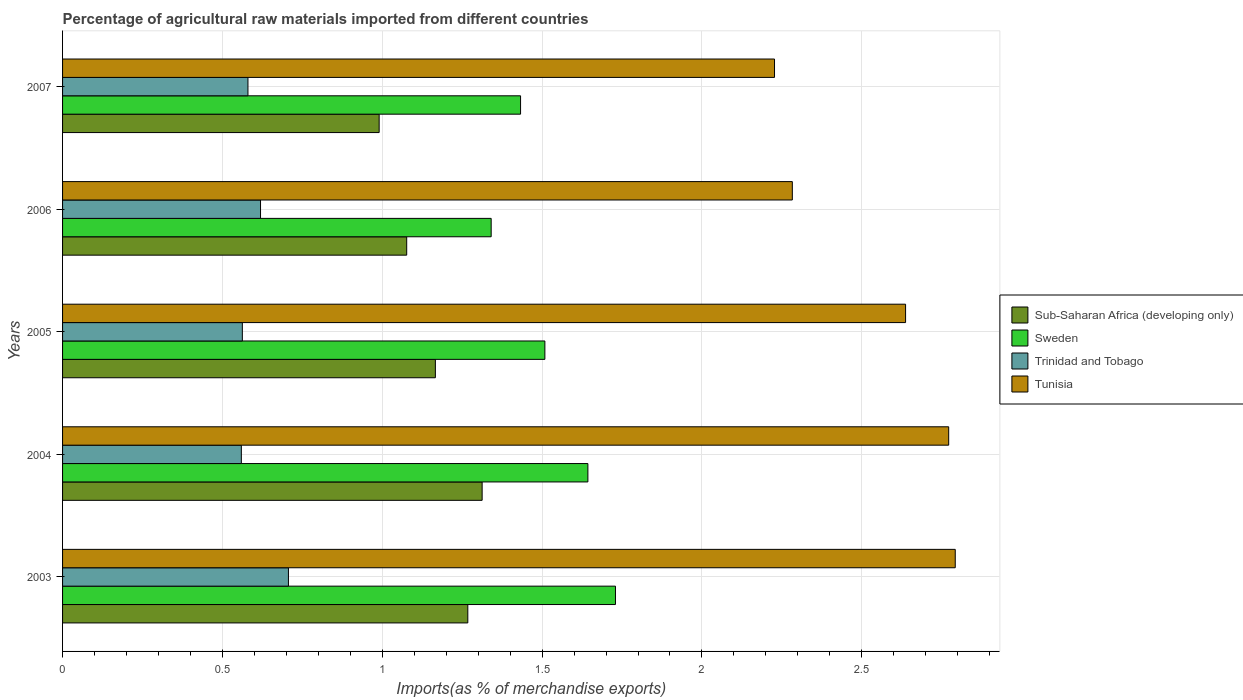How many different coloured bars are there?
Provide a short and direct response. 4. How many groups of bars are there?
Your answer should be compact. 5. How many bars are there on the 3rd tick from the top?
Your answer should be compact. 4. In how many cases, is the number of bars for a given year not equal to the number of legend labels?
Give a very brief answer. 0. What is the percentage of imports to different countries in Sweden in 2005?
Keep it short and to the point. 1.51. Across all years, what is the maximum percentage of imports to different countries in Sweden?
Provide a short and direct response. 1.73. Across all years, what is the minimum percentage of imports to different countries in Trinidad and Tobago?
Offer a very short reply. 0.56. What is the total percentage of imports to different countries in Tunisia in the graph?
Your answer should be compact. 12.71. What is the difference between the percentage of imports to different countries in Sub-Saharan Africa (developing only) in 2004 and that in 2006?
Your response must be concise. 0.24. What is the difference between the percentage of imports to different countries in Sweden in 2006 and the percentage of imports to different countries in Sub-Saharan Africa (developing only) in 2007?
Your answer should be compact. 0.35. What is the average percentage of imports to different countries in Sweden per year?
Ensure brevity in your answer.  1.53. In the year 2006, what is the difference between the percentage of imports to different countries in Sweden and percentage of imports to different countries in Tunisia?
Your response must be concise. -0.94. What is the ratio of the percentage of imports to different countries in Sweden in 2004 to that in 2006?
Provide a succinct answer. 1.23. Is the percentage of imports to different countries in Tunisia in 2005 less than that in 2006?
Make the answer very short. No. What is the difference between the highest and the second highest percentage of imports to different countries in Tunisia?
Your response must be concise. 0.02. What is the difference between the highest and the lowest percentage of imports to different countries in Sweden?
Offer a terse response. 0.39. In how many years, is the percentage of imports to different countries in Sub-Saharan Africa (developing only) greater than the average percentage of imports to different countries in Sub-Saharan Africa (developing only) taken over all years?
Provide a short and direct response. 3. Is the sum of the percentage of imports to different countries in Sweden in 2006 and 2007 greater than the maximum percentage of imports to different countries in Trinidad and Tobago across all years?
Your answer should be compact. Yes. Is it the case that in every year, the sum of the percentage of imports to different countries in Tunisia and percentage of imports to different countries in Sub-Saharan Africa (developing only) is greater than the sum of percentage of imports to different countries in Sweden and percentage of imports to different countries in Trinidad and Tobago?
Your answer should be compact. No. What does the 1st bar from the top in 2004 represents?
Offer a very short reply. Tunisia. What does the 3rd bar from the bottom in 2004 represents?
Ensure brevity in your answer.  Trinidad and Tobago. Is it the case that in every year, the sum of the percentage of imports to different countries in Trinidad and Tobago and percentage of imports to different countries in Sub-Saharan Africa (developing only) is greater than the percentage of imports to different countries in Sweden?
Keep it short and to the point. Yes. How many years are there in the graph?
Provide a succinct answer. 5. Are the values on the major ticks of X-axis written in scientific E-notation?
Make the answer very short. No. Does the graph contain any zero values?
Give a very brief answer. No. Does the graph contain grids?
Ensure brevity in your answer.  Yes. How many legend labels are there?
Keep it short and to the point. 4. What is the title of the graph?
Your answer should be very brief. Percentage of agricultural raw materials imported from different countries. What is the label or title of the X-axis?
Give a very brief answer. Imports(as % of merchandise exports). What is the Imports(as % of merchandise exports) in Sub-Saharan Africa (developing only) in 2003?
Provide a succinct answer. 1.27. What is the Imports(as % of merchandise exports) in Sweden in 2003?
Make the answer very short. 1.73. What is the Imports(as % of merchandise exports) in Trinidad and Tobago in 2003?
Your answer should be very brief. 0.71. What is the Imports(as % of merchandise exports) of Tunisia in 2003?
Make the answer very short. 2.79. What is the Imports(as % of merchandise exports) of Sub-Saharan Africa (developing only) in 2004?
Make the answer very short. 1.31. What is the Imports(as % of merchandise exports) of Sweden in 2004?
Give a very brief answer. 1.64. What is the Imports(as % of merchandise exports) of Trinidad and Tobago in 2004?
Provide a short and direct response. 0.56. What is the Imports(as % of merchandise exports) in Tunisia in 2004?
Offer a very short reply. 2.77. What is the Imports(as % of merchandise exports) of Sub-Saharan Africa (developing only) in 2005?
Provide a succinct answer. 1.17. What is the Imports(as % of merchandise exports) in Sweden in 2005?
Make the answer very short. 1.51. What is the Imports(as % of merchandise exports) of Trinidad and Tobago in 2005?
Your answer should be very brief. 0.56. What is the Imports(as % of merchandise exports) in Tunisia in 2005?
Offer a very short reply. 2.64. What is the Imports(as % of merchandise exports) in Sub-Saharan Africa (developing only) in 2006?
Keep it short and to the point. 1.08. What is the Imports(as % of merchandise exports) in Sweden in 2006?
Give a very brief answer. 1.34. What is the Imports(as % of merchandise exports) of Trinidad and Tobago in 2006?
Offer a terse response. 0.62. What is the Imports(as % of merchandise exports) in Tunisia in 2006?
Keep it short and to the point. 2.28. What is the Imports(as % of merchandise exports) in Sub-Saharan Africa (developing only) in 2007?
Make the answer very short. 0.99. What is the Imports(as % of merchandise exports) in Sweden in 2007?
Your answer should be compact. 1.43. What is the Imports(as % of merchandise exports) in Trinidad and Tobago in 2007?
Your answer should be very brief. 0.58. What is the Imports(as % of merchandise exports) of Tunisia in 2007?
Give a very brief answer. 2.23. Across all years, what is the maximum Imports(as % of merchandise exports) of Sub-Saharan Africa (developing only)?
Your answer should be very brief. 1.31. Across all years, what is the maximum Imports(as % of merchandise exports) in Sweden?
Provide a succinct answer. 1.73. Across all years, what is the maximum Imports(as % of merchandise exports) of Trinidad and Tobago?
Offer a terse response. 0.71. Across all years, what is the maximum Imports(as % of merchandise exports) in Tunisia?
Your answer should be very brief. 2.79. Across all years, what is the minimum Imports(as % of merchandise exports) of Sub-Saharan Africa (developing only)?
Offer a terse response. 0.99. Across all years, what is the minimum Imports(as % of merchandise exports) of Sweden?
Provide a short and direct response. 1.34. Across all years, what is the minimum Imports(as % of merchandise exports) in Trinidad and Tobago?
Provide a short and direct response. 0.56. Across all years, what is the minimum Imports(as % of merchandise exports) of Tunisia?
Keep it short and to the point. 2.23. What is the total Imports(as % of merchandise exports) in Sub-Saharan Africa (developing only) in the graph?
Keep it short and to the point. 5.81. What is the total Imports(as % of merchandise exports) in Sweden in the graph?
Offer a terse response. 7.65. What is the total Imports(as % of merchandise exports) in Trinidad and Tobago in the graph?
Give a very brief answer. 3.03. What is the total Imports(as % of merchandise exports) in Tunisia in the graph?
Your response must be concise. 12.71. What is the difference between the Imports(as % of merchandise exports) in Sub-Saharan Africa (developing only) in 2003 and that in 2004?
Give a very brief answer. -0.04. What is the difference between the Imports(as % of merchandise exports) of Sweden in 2003 and that in 2004?
Provide a succinct answer. 0.09. What is the difference between the Imports(as % of merchandise exports) of Trinidad and Tobago in 2003 and that in 2004?
Make the answer very short. 0.15. What is the difference between the Imports(as % of merchandise exports) of Tunisia in 2003 and that in 2004?
Make the answer very short. 0.02. What is the difference between the Imports(as % of merchandise exports) of Sub-Saharan Africa (developing only) in 2003 and that in 2005?
Keep it short and to the point. 0.1. What is the difference between the Imports(as % of merchandise exports) of Sweden in 2003 and that in 2005?
Provide a succinct answer. 0.22. What is the difference between the Imports(as % of merchandise exports) of Trinidad and Tobago in 2003 and that in 2005?
Keep it short and to the point. 0.14. What is the difference between the Imports(as % of merchandise exports) in Tunisia in 2003 and that in 2005?
Make the answer very short. 0.16. What is the difference between the Imports(as % of merchandise exports) in Sub-Saharan Africa (developing only) in 2003 and that in 2006?
Ensure brevity in your answer.  0.19. What is the difference between the Imports(as % of merchandise exports) in Sweden in 2003 and that in 2006?
Ensure brevity in your answer.  0.39. What is the difference between the Imports(as % of merchandise exports) of Trinidad and Tobago in 2003 and that in 2006?
Provide a short and direct response. 0.09. What is the difference between the Imports(as % of merchandise exports) in Tunisia in 2003 and that in 2006?
Ensure brevity in your answer.  0.51. What is the difference between the Imports(as % of merchandise exports) of Sub-Saharan Africa (developing only) in 2003 and that in 2007?
Ensure brevity in your answer.  0.28. What is the difference between the Imports(as % of merchandise exports) of Sweden in 2003 and that in 2007?
Offer a terse response. 0.3. What is the difference between the Imports(as % of merchandise exports) in Trinidad and Tobago in 2003 and that in 2007?
Make the answer very short. 0.13. What is the difference between the Imports(as % of merchandise exports) of Tunisia in 2003 and that in 2007?
Provide a short and direct response. 0.57. What is the difference between the Imports(as % of merchandise exports) in Sub-Saharan Africa (developing only) in 2004 and that in 2005?
Keep it short and to the point. 0.15. What is the difference between the Imports(as % of merchandise exports) in Sweden in 2004 and that in 2005?
Provide a succinct answer. 0.13. What is the difference between the Imports(as % of merchandise exports) of Trinidad and Tobago in 2004 and that in 2005?
Give a very brief answer. -0. What is the difference between the Imports(as % of merchandise exports) in Tunisia in 2004 and that in 2005?
Give a very brief answer. 0.13. What is the difference between the Imports(as % of merchandise exports) in Sub-Saharan Africa (developing only) in 2004 and that in 2006?
Make the answer very short. 0.24. What is the difference between the Imports(as % of merchandise exports) in Sweden in 2004 and that in 2006?
Provide a short and direct response. 0.3. What is the difference between the Imports(as % of merchandise exports) of Trinidad and Tobago in 2004 and that in 2006?
Your response must be concise. -0.06. What is the difference between the Imports(as % of merchandise exports) in Tunisia in 2004 and that in 2006?
Your answer should be compact. 0.49. What is the difference between the Imports(as % of merchandise exports) in Sub-Saharan Africa (developing only) in 2004 and that in 2007?
Provide a succinct answer. 0.32. What is the difference between the Imports(as % of merchandise exports) of Sweden in 2004 and that in 2007?
Your answer should be compact. 0.21. What is the difference between the Imports(as % of merchandise exports) of Trinidad and Tobago in 2004 and that in 2007?
Give a very brief answer. -0.02. What is the difference between the Imports(as % of merchandise exports) of Tunisia in 2004 and that in 2007?
Your answer should be compact. 0.54. What is the difference between the Imports(as % of merchandise exports) in Sub-Saharan Africa (developing only) in 2005 and that in 2006?
Your answer should be compact. 0.09. What is the difference between the Imports(as % of merchandise exports) in Sweden in 2005 and that in 2006?
Make the answer very short. 0.17. What is the difference between the Imports(as % of merchandise exports) in Trinidad and Tobago in 2005 and that in 2006?
Provide a succinct answer. -0.06. What is the difference between the Imports(as % of merchandise exports) in Tunisia in 2005 and that in 2006?
Your response must be concise. 0.35. What is the difference between the Imports(as % of merchandise exports) in Sub-Saharan Africa (developing only) in 2005 and that in 2007?
Keep it short and to the point. 0.18. What is the difference between the Imports(as % of merchandise exports) in Sweden in 2005 and that in 2007?
Keep it short and to the point. 0.08. What is the difference between the Imports(as % of merchandise exports) of Trinidad and Tobago in 2005 and that in 2007?
Ensure brevity in your answer.  -0.02. What is the difference between the Imports(as % of merchandise exports) in Tunisia in 2005 and that in 2007?
Give a very brief answer. 0.41. What is the difference between the Imports(as % of merchandise exports) in Sub-Saharan Africa (developing only) in 2006 and that in 2007?
Offer a terse response. 0.09. What is the difference between the Imports(as % of merchandise exports) of Sweden in 2006 and that in 2007?
Offer a very short reply. -0.09. What is the difference between the Imports(as % of merchandise exports) in Trinidad and Tobago in 2006 and that in 2007?
Your answer should be compact. 0.04. What is the difference between the Imports(as % of merchandise exports) in Tunisia in 2006 and that in 2007?
Your answer should be compact. 0.06. What is the difference between the Imports(as % of merchandise exports) in Sub-Saharan Africa (developing only) in 2003 and the Imports(as % of merchandise exports) in Sweden in 2004?
Provide a succinct answer. -0.38. What is the difference between the Imports(as % of merchandise exports) of Sub-Saharan Africa (developing only) in 2003 and the Imports(as % of merchandise exports) of Trinidad and Tobago in 2004?
Your answer should be very brief. 0.71. What is the difference between the Imports(as % of merchandise exports) in Sub-Saharan Africa (developing only) in 2003 and the Imports(as % of merchandise exports) in Tunisia in 2004?
Your answer should be very brief. -1.5. What is the difference between the Imports(as % of merchandise exports) of Sweden in 2003 and the Imports(as % of merchandise exports) of Trinidad and Tobago in 2004?
Your answer should be very brief. 1.17. What is the difference between the Imports(as % of merchandise exports) of Sweden in 2003 and the Imports(as % of merchandise exports) of Tunisia in 2004?
Offer a terse response. -1.04. What is the difference between the Imports(as % of merchandise exports) of Trinidad and Tobago in 2003 and the Imports(as % of merchandise exports) of Tunisia in 2004?
Ensure brevity in your answer.  -2.07. What is the difference between the Imports(as % of merchandise exports) in Sub-Saharan Africa (developing only) in 2003 and the Imports(as % of merchandise exports) in Sweden in 2005?
Make the answer very short. -0.24. What is the difference between the Imports(as % of merchandise exports) in Sub-Saharan Africa (developing only) in 2003 and the Imports(as % of merchandise exports) in Trinidad and Tobago in 2005?
Your response must be concise. 0.71. What is the difference between the Imports(as % of merchandise exports) in Sub-Saharan Africa (developing only) in 2003 and the Imports(as % of merchandise exports) in Tunisia in 2005?
Offer a terse response. -1.37. What is the difference between the Imports(as % of merchandise exports) of Sweden in 2003 and the Imports(as % of merchandise exports) of Trinidad and Tobago in 2005?
Keep it short and to the point. 1.17. What is the difference between the Imports(as % of merchandise exports) of Sweden in 2003 and the Imports(as % of merchandise exports) of Tunisia in 2005?
Provide a succinct answer. -0.91. What is the difference between the Imports(as % of merchandise exports) in Trinidad and Tobago in 2003 and the Imports(as % of merchandise exports) in Tunisia in 2005?
Your answer should be compact. -1.93. What is the difference between the Imports(as % of merchandise exports) in Sub-Saharan Africa (developing only) in 2003 and the Imports(as % of merchandise exports) in Sweden in 2006?
Your answer should be very brief. -0.07. What is the difference between the Imports(as % of merchandise exports) in Sub-Saharan Africa (developing only) in 2003 and the Imports(as % of merchandise exports) in Trinidad and Tobago in 2006?
Offer a very short reply. 0.65. What is the difference between the Imports(as % of merchandise exports) of Sub-Saharan Africa (developing only) in 2003 and the Imports(as % of merchandise exports) of Tunisia in 2006?
Provide a short and direct response. -1.02. What is the difference between the Imports(as % of merchandise exports) of Sweden in 2003 and the Imports(as % of merchandise exports) of Trinidad and Tobago in 2006?
Your answer should be very brief. 1.11. What is the difference between the Imports(as % of merchandise exports) in Sweden in 2003 and the Imports(as % of merchandise exports) in Tunisia in 2006?
Offer a terse response. -0.55. What is the difference between the Imports(as % of merchandise exports) in Trinidad and Tobago in 2003 and the Imports(as % of merchandise exports) in Tunisia in 2006?
Ensure brevity in your answer.  -1.58. What is the difference between the Imports(as % of merchandise exports) of Sub-Saharan Africa (developing only) in 2003 and the Imports(as % of merchandise exports) of Sweden in 2007?
Provide a short and direct response. -0.17. What is the difference between the Imports(as % of merchandise exports) in Sub-Saharan Africa (developing only) in 2003 and the Imports(as % of merchandise exports) in Trinidad and Tobago in 2007?
Ensure brevity in your answer.  0.69. What is the difference between the Imports(as % of merchandise exports) in Sub-Saharan Africa (developing only) in 2003 and the Imports(as % of merchandise exports) in Tunisia in 2007?
Your response must be concise. -0.96. What is the difference between the Imports(as % of merchandise exports) in Sweden in 2003 and the Imports(as % of merchandise exports) in Trinidad and Tobago in 2007?
Keep it short and to the point. 1.15. What is the difference between the Imports(as % of merchandise exports) in Sweden in 2003 and the Imports(as % of merchandise exports) in Tunisia in 2007?
Provide a short and direct response. -0.5. What is the difference between the Imports(as % of merchandise exports) of Trinidad and Tobago in 2003 and the Imports(as % of merchandise exports) of Tunisia in 2007?
Your response must be concise. -1.52. What is the difference between the Imports(as % of merchandise exports) of Sub-Saharan Africa (developing only) in 2004 and the Imports(as % of merchandise exports) of Sweden in 2005?
Give a very brief answer. -0.2. What is the difference between the Imports(as % of merchandise exports) in Sub-Saharan Africa (developing only) in 2004 and the Imports(as % of merchandise exports) in Trinidad and Tobago in 2005?
Ensure brevity in your answer.  0.75. What is the difference between the Imports(as % of merchandise exports) of Sub-Saharan Africa (developing only) in 2004 and the Imports(as % of merchandise exports) of Tunisia in 2005?
Your response must be concise. -1.32. What is the difference between the Imports(as % of merchandise exports) in Sweden in 2004 and the Imports(as % of merchandise exports) in Trinidad and Tobago in 2005?
Provide a short and direct response. 1.08. What is the difference between the Imports(as % of merchandise exports) of Sweden in 2004 and the Imports(as % of merchandise exports) of Tunisia in 2005?
Offer a terse response. -0.99. What is the difference between the Imports(as % of merchandise exports) in Trinidad and Tobago in 2004 and the Imports(as % of merchandise exports) in Tunisia in 2005?
Ensure brevity in your answer.  -2.08. What is the difference between the Imports(as % of merchandise exports) of Sub-Saharan Africa (developing only) in 2004 and the Imports(as % of merchandise exports) of Sweden in 2006?
Your response must be concise. -0.03. What is the difference between the Imports(as % of merchandise exports) of Sub-Saharan Africa (developing only) in 2004 and the Imports(as % of merchandise exports) of Trinidad and Tobago in 2006?
Keep it short and to the point. 0.69. What is the difference between the Imports(as % of merchandise exports) in Sub-Saharan Africa (developing only) in 2004 and the Imports(as % of merchandise exports) in Tunisia in 2006?
Provide a short and direct response. -0.97. What is the difference between the Imports(as % of merchandise exports) in Sweden in 2004 and the Imports(as % of merchandise exports) in Trinidad and Tobago in 2006?
Ensure brevity in your answer.  1.02. What is the difference between the Imports(as % of merchandise exports) in Sweden in 2004 and the Imports(as % of merchandise exports) in Tunisia in 2006?
Offer a very short reply. -0.64. What is the difference between the Imports(as % of merchandise exports) of Trinidad and Tobago in 2004 and the Imports(as % of merchandise exports) of Tunisia in 2006?
Your response must be concise. -1.72. What is the difference between the Imports(as % of merchandise exports) in Sub-Saharan Africa (developing only) in 2004 and the Imports(as % of merchandise exports) in Sweden in 2007?
Provide a succinct answer. -0.12. What is the difference between the Imports(as % of merchandise exports) of Sub-Saharan Africa (developing only) in 2004 and the Imports(as % of merchandise exports) of Trinidad and Tobago in 2007?
Keep it short and to the point. 0.73. What is the difference between the Imports(as % of merchandise exports) of Sub-Saharan Africa (developing only) in 2004 and the Imports(as % of merchandise exports) of Tunisia in 2007?
Ensure brevity in your answer.  -0.91. What is the difference between the Imports(as % of merchandise exports) of Sweden in 2004 and the Imports(as % of merchandise exports) of Trinidad and Tobago in 2007?
Provide a succinct answer. 1.06. What is the difference between the Imports(as % of merchandise exports) in Sweden in 2004 and the Imports(as % of merchandise exports) in Tunisia in 2007?
Give a very brief answer. -0.58. What is the difference between the Imports(as % of merchandise exports) of Trinidad and Tobago in 2004 and the Imports(as % of merchandise exports) of Tunisia in 2007?
Your response must be concise. -1.67. What is the difference between the Imports(as % of merchandise exports) of Sub-Saharan Africa (developing only) in 2005 and the Imports(as % of merchandise exports) of Sweden in 2006?
Offer a terse response. -0.17. What is the difference between the Imports(as % of merchandise exports) in Sub-Saharan Africa (developing only) in 2005 and the Imports(as % of merchandise exports) in Trinidad and Tobago in 2006?
Provide a succinct answer. 0.55. What is the difference between the Imports(as % of merchandise exports) in Sub-Saharan Africa (developing only) in 2005 and the Imports(as % of merchandise exports) in Tunisia in 2006?
Provide a short and direct response. -1.12. What is the difference between the Imports(as % of merchandise exports) in Sweden in 2005 and the Imports(as % of merchandise exports) in Trinidad and Tobago in 2006?
Make the answer very short. 0.89. What is the difference between the Imports(as % of merchandise exports) of Sweden in 2005 and the Imports(as % of merchandise exports) of Tunisia in 2006?
Your response must be concise. -0.77. What is the difference between the Imports(as % of merchandise exports) in Trinidad and Tobago in 2005 and the Imports(as % of merchandise exports) in Tunisia in 2006?
Your answer should be compact. -1.72. What is the difference between the Imports(as % of merchandise exports) of Sub-Saharan Africa (developing only) in 2005 and the Imports(as % of merchandise exports) of Sweden in 2007?
Your answer should be very brief. -0.27. What is the difference between the Imports(as % of merchandise exports) in Sub-Saharan Africa (developing only) in 2005 and the Imports(as % of merchandise exports) in Trinidad and Tobago in 2007?
Keep it short and to the point. 0.59. What is the difference between the Imports(as % of merchandise exports) of Sub-Saharan Africa (developing only) in 2005 and the Imports(as % of merchandise exports) of Tunisia in 2007?
Ensure brevity in your answer.  -1.06. What is the difference between the Imports(as % of merchandise exports) in Sweden in 2005 and the Imports(as % of merchandise exports) in Trinidad and Tobago in 2007?
Offer a very short reply. 0.93. What is the difference between the Imports(as % of merchandise exports) of Sweden in 2005 and the Imports(as % of merchandise exports) of Tunisia in 2007?
Ensure brevity in your answer.  -0.72. What is the difference between the Imports(as % of merchandise exports) in Trinidad and Tobago in 2005 and the Imports(as % of merchandise exports) in Tunisia in 2007?
Provide a short and direct response. -1.66. What is the difference between the Imports(as % of merchandise exports) of Sub-Saharan Africa (developing only) in 2006 and the Imports(as % of merchandise exports) of Sweden in 2007?
Make the answer very short. -0.36. What is the difference between the Imports(as % of merchandise exports) of Sub-Saharan Africa (developing only) in 2006 and the Imports(as % of merchandise exports) of Trinidad and Tobago in 2007?
Offer a terse response. 0.5. What is the difference between the Imports(as % of merchandise exports) in Sub-Saharan Africa (developing only) in 2006 and the Imports(as % of merchandise exports) in Tunisia in 2007?
Ensure brevity in your answer.  -1.15. What is the difference between the Imports(as % of merchandise exports) in Sweden in 2006 and the Imports(as % of merchandise exports) in Trinidad and Tobago in 2007?
Ensure brevity in your answer.  0.76. What is the difference between the Imports(as % of merchandise exports) of Sweden in 2006 and the Imports(as % of merchandise exports) of Tunisia in 2007?
Ensure brevity in your answer.  -0.89. What is the difference between the Imports(as % of merchandise exports) of Trinidad and Tobago in 2006 and the Imports(as % of merchandise exports) of Tunisia in 2007?
Offer a very short reply. -1.61. What is the average Imports(as % of merchandise exports) in Sub-Saharan Africa (developing only) per year?
Provide a succinct answer. 1.16. What is the average Imports(as % of merchandise exports) in Sweden per year?
Make the answer very short. 1.53. What is the average Imports(as % of merchandise exports) in Trinidad and Tobago per year?
Provide a short and direct response. 0.61. What is the average Imports(as % of merchandise exports) in Tunisia per year?
Keep it short and to the point. 2.54. In the year 2003, what is the difference between the Imports(as % of merchandise exports) of Sub-Saharan Africa (developing only) and Imports(as % of merchandise exports) of Sweden?
Offer a very short reply. -0.46. In the year 2003, what is the difference between the Imports(as % of merchandise exports) of Sub-Saharan Africa (developing only) and Imports(as % of merchandise exports) of Trinidad and Tobago?
Provide a succinct answer. 0.56. In the year 2003, what is the difference between the Imports(as % of merchandise exports) in Sub-Saharan Africa (developing only) and Imports(as % of merchandise exports) in Tunisia?
Keep it short and to the point. -1.52. In the year 2003, what is the difference between the Imports(as % of merchandise exports) in Sweden and Imports(as % of merchandise exports) in Trinidad and Tobago?
Your response must be concise. 1.02. In the year 2003, what is the difference between the Imports(as % of merchandise exports) of Sweden and Imports(as % of merchandise exports) of Tunisia?
Provide a short and direct response. -1.06. In the year 2003, what is the difference between the Imports(as % of merchandise exports) in Trinidad and Tobago and Imports(as % of merchandise exports) in Tunisia?
Provide a succinct answer. -2.09. In the year 2004, what is the difference between the Imports(as % of merchandise exports) in Sub-Saharan Africa (developing only) and Imports(as % of merchandise exports) in Sweden?
Offer a terse response. -0.33. In the year 2004, what is the difference between the Imports(as % of merchandise exports) of Sub-Saharan Africa (developing only) and Imports(as % of merchandise exports) of Trinidad and Tobago?
Your response must be concise. 0.75. In the year 2004, what is the difference between the Imports(as % of merchandise exports) in Sub-Saharan Africa (developing only) and Imports(as % of merchandise exports) in Tunisia?
Keep it short and to the point. -1.46. In the year 2004, what is the difference between the Imports(as % of merchandise exports) of Sweden and Imports(as % of merchandise exports) of Trinidad and Tobago?
Offer a very short reply. 1.08. In the year 2004, what is the difference between the Imports(as % of merchandise exports) of Sweden and Imports(as % of merchandise exports) of Tunisia?
Provide a succinct answer. -1.13. In the year 2004, what is the difference between the Imports(as % of merchandise exports) in Trinidad and Tobago and Imports(as % of merchandise exports) in Tunisia?
Give a very brief answer. -2.21. In the year 2005, what is the difference between the Imports(as % of merchandise exports) of Sub-Saharan Africa (developing only) and Imports(as % of merchandise exports) of Sweden?
Give a very brief answer. -0.34. In the year 2005, what is the difference between the Imports(as % of merchandise exports) of Sub-Saharan Africa (developing only) and Imports(as % of merchandise exports) of Trinidad and Tobago?
Your answer should be compact. 0.6. In the year 2005, what is the difference between the Imports(as % of merchandise exports) of Sub-Saharan Africa (developing only) and Imports(as % of merchandise exports) of Tunisia?
Give a very brief answer. -1.47. In the year 2005, what is the difference between the Imports(as % of merchandise exports) in Sweden and Imports(as % of merchandise exports) in Trinidad and Tobago?
Your answer should be very brief. 0.95. In the year 2005, what is the difference between the Imports(as % of merchandise exports) of Sweden and Imports(as % of merchandise exports) of Tunisia?
Provide a succinct answer. -1.13. In the year 2005, what is the difference between the Imports(as % of merchandise exports) in Trinidad and Tobago and Imports(as % of merchandise exports) in Tunisia?
Ensure brevity in your answer.  -2.07. In the year 2006, what is the difference between the Imports(as % of merchandise exports) of Sub-Saharan Africa (developing only) and Imports(as % of merchandise exports) of Sweden?
Your answer should be compact. -0.26. In the year 2006, what is the difference between the Imports(as % of merchandise exports) of Sub-Saharan Africa (developing only) and Imports(as % of merchandise exports) of Trinidad and Tobago?
Give a very brief answer. 0.46. In the year 2006, what is the difference between the Imports(as % of merchandise exports) of Sub-Saharan Africa (developing only) and Imports(as % of merchandise exports) of Tunisia?
Provide a short and direct response. -1.21. In the year 2006, what is the difference between the Imports(as % of merchandise exports) of Sweden and Imports(as % of merchandise exports) of Trinidad and Tobago?
Provide a short and direct response. 0.72. In the year 2006, what is the difference between the Imports(as % of merchandise exports) in Sweden and Imports(as % of merchandise exports) in Tunisia?
Keep it short and to the point. -0.94. In the year 2006, what is the difference between the Imports(as % of merchandise exports) of Trinidad and Tobago and Imports(as % of merchandise exports) of Tunisia?
Give a very brief answer. -1.66. In the year 2007, what is the difference between the Imports(as % of merchandise exports) of Sub-Saharan Africa (developing only) and Imports(as % of merchandise exports) of Sweden?
Offer a terse response. -0.44. In the year 2007, what is the difference between the Imports(as % of merchandise exports) in Sub-Saharan Africa (developing only) and Imports(as % of merchandise exports) in Trinidad and Tobago?
Offer a terse response. 0.41. In the year 2007, what is the difference between the Imports(as % of merchandise exports) of Sub-Saharan Africa (developing only) and Imports(as % of merchandise exports) of Tunisia?
Make the answer very short. -1.24. In the year 2007, what is the difference between the Imports(as % of merchandise exports) of Sweden and Imports(as % of merchandise exports) of Trinidad and Tobago?
Provide a short and direct response. 0.85. In the year 2007, what is the difference between the Imports(as % of merchandise exports) in Sweden and Imports(as % of merchandise exports) in Tunisia?
Provide a short and direct response. -0.79. In the year 2007, what is the difference between the Imports(as % of merchandise exports) of Trinidad and Tobago and Imports(as % of merchandise exports) of Tunisia?
Your response must be concise. -1.65. What is the ratio of the Imports(as % of merchandise exports) in Sub-Saharan Africa (developing only) in 2003 to that in 2004?
Your answer should be very brief. 0.97. What is the ratio of the Imports(as % of merchandise exports) in Sweden in 2003 to that in 2004?
Provide a short and direct response. 1.05. What is the ratio of the Imports(as % of merchandise exports) in Trinidad and Tobago in 2003 to that in 2004?
Provide a short and direct response. 1.26. What is the ratio of the Imports(as % of merchandise exports) of Tunisia in 2003 to that in 2004?
Offer a terse response. 1.01. What is the ratio of the Imports(as % of merchandise exports) in Sub-Saharan Africa (developing only) in 2003 to that in 2005?
Offer a terse response. 1.09. What is the ratio of the Imports(as % of merchandise exports) in Sweden in 2003 to that in 2005?
Keep it short and to the point. 1.15. What is the ratio of the Imports(as % of merchandise exports) of Trinidad and Tobago in 2003 to that in 2005?
Offer a terse response. 1.26. What is the ratio of the Imports(as % of merchandise exports) of Tunisia in 2003 to that in 2005?
Make the answer very short. 1.06. What is the ratio of the Imports(as % of merchandise exports) of Sub-Saharan Africa (developing only) in 2003 to that in 2006?
Your answer should be compact. 1.18. What is the ratio of the Imports(as % of merchandise exports) of Sweden in 2003 to that in 2006?
Provide a succinct answer. 1.29. What is the ratio of the Imports(as % of merchandise exports) of Trinidad and Tobago in 2003 to that in 2006?
Offer a terse response. 1.14. What is the ratio of the Imports(as % of merchandise exports) in Tunisia in 2003 to that in 2006?
Keep it short and to the point. 1.22. What is the ratio of the Imports(as % of merchandise exports) of Sub-Saharan Africa (developing only) in 2003 to that in 2007?
Provide a short and direct response. 1.28. What is the ratio of the Imports(as % of merchandise exports) in Sweden in 2003 to that in 2007?
Provide a succinct answer. 1.21. What is the ratio of the Imports(as % of merchandise exports) of Trinidad and Tobago in 2003 to that in 2007?
Ensure brevity in your answer.  1.22. What is the ratio of the Imports(as % of merchandise exports) in Tunisia in 2003 to that in 2007?
Offer a very short reply. 1.25. What is the ratio of the Imports(as % of merchandise exports) of Sub-Saharan Africa (developing only) in 2004 to that in 2005?
Offer a terse response. 1.13. What is the ratio of the Imports(as % of merchandise exports) of Sweden in 2004 to that in 2005?
Your answer should be compact. 1.09. What is the ratio of the Imports(as % of merchandise exports) in Tunisia in 2004 to that in 2005?
Keep it short and to the point. 1.05. What is the ratio of the Imports(as % of merchandise exports) of Sub-Saharan Africa (developing only) in 2004 to that in 2006?
Ensure brevity in your answer.  1.22. What is the ratio of the Imports(as % of merchandise exports) in Sweden in 2004 to that in 2006?
Keep it short and to the point. 1.23. What is the ratio of the Imports(as % of merchandise exports) in Trinidad and Tobago in 2004 to that in 2006?
Your answer should be very brief. 0.9. What is the ratio of the Imports(as % of merchandise exports) of Tunisia in 2004 to that in 2006?
Your answer should be very brief. 1.21. What is the ratio of the Imports(as % of merchandise exports) in Sub-Saharan Africa (developing only) in 2004 to that in 2007?
Offer a terse response. 1.33. What is the ratio of the Imports(as % of merchandise exports) of Sweden in 2004 to that in 2007?
Your answer should be compact. 1.15. What is the ratio of the Imports(as % of merchandise exports) of Trinidad and Tobago in 2004 to that in 2007?
Your response must be concise. 0.96. What is the ratio of the Imports(as % of merchandise exports) in Tunisia in 2004 to that in 2007?
Offer a very short reply. 1.24. What is the ratio of the Imports(as % of merchandise exports) in Sub-Saharan Africa (developing only) in 2005 to that in 2006?
Give a very brief answer. 1.08. What is the ratio of the Imports(as % of merchandise exports) in Sweden in 2005 to that in 2006?
Provide a succinct answer. 1.13. What is the ratio of the Imports(as % of merchandise exports) of Trinidad and Tobago in 2005 to that in 2006?
Provide a short and direct response. 0.91. What is the ratio of the Imports(as % of merchandise exports) of Tunisia in 2005 to that in 2006?
Provide a succinct answer. 1.16. What is the ratio of the Imports(as % of merchandise exports) of Sub-Saharan Africa (developing only) in 2005 to that in 2007?
Provide a succinct answer. 1.18. What is the ratio of the Imports(as % of merchandise exports) of Sweden in 2005 to that in 2007?
Your answer should be compact. 1.05. What is the ratio of the Imports(as % of merchandise exports) in Trinidad and Tobago in 2005 to that in 2007?
Your answer should be compact. 0.97. What is the ratio of the Imports(as % of merchandise exports) in Tunisia in 2005 to that in 2007?
Offer a terse response. 1.18. What is the ratio of the Imports(as % of merchandise exports) of Sub-Saharan Africa (developing only) in 2006 to that in 2007?
Offer a very short reply. 1.09. What is the ratio of the Imports(as % of merchandise exports) of Sweden in 2006 to that in 2007?
Keep it short and to the point. 0.94. What is the ratio of the Imports(as % of merchandise exports) in Trinidad and Tobago in 2006 to that in 2007?
Your answer should be very brief. 1.07. What is the ratio of the Imports(as % of merchandise exports) in Tunisia in 2006 to that in 2007?
Ensure brevity in your answer.  1.02. What is the difference between the highest and the second highest Imports(as % of merchandise exports) of Sub-Saharan Africa (developing only)?
Provide a short and direct response. 0.04. What is the difference between the highest and the second highest Imports(as % of merchandise exports) in Sweden?
Provide a short and direct response. 0.09. What is the difference between the highest and the second highest Imports(as % of merchandise exports) of Trinidad and Tobago?
Give a very brief answer. 0.09. What is the difference between the highest and the second highest Imports(as % of merchandise exports) of Tunisia?
Make the answer very short. 0.02. What is the difference between the highest and the lowest Imports(as % of merchandise exports) in Sub-Saharan Africa (developing only)?
Your answer should be compact. 0.32. What is the difference between the highest and the lowest Imports(as % of merchandise exports) in Sweden?
Keep it short and to the point. 0.39. What is the difference between the highest and the lowest Imports(as % of merchandise exports) in Trinidad and Tobago?
Offer a terse response. 0.15. What is the difference between the highest and the lowest Imports(as % of merchandise exports) of Tunisia?
Provide a short and direct response. 0.57. 